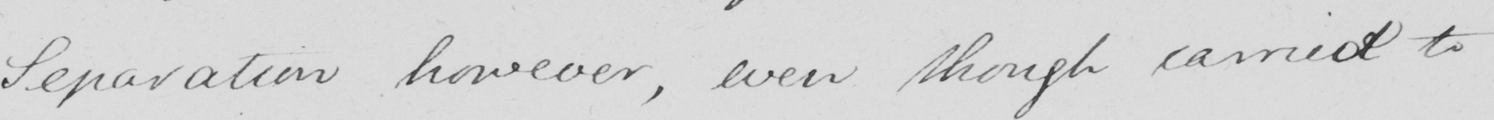What text is written in this handwritten line? Separation however , even though carried to 